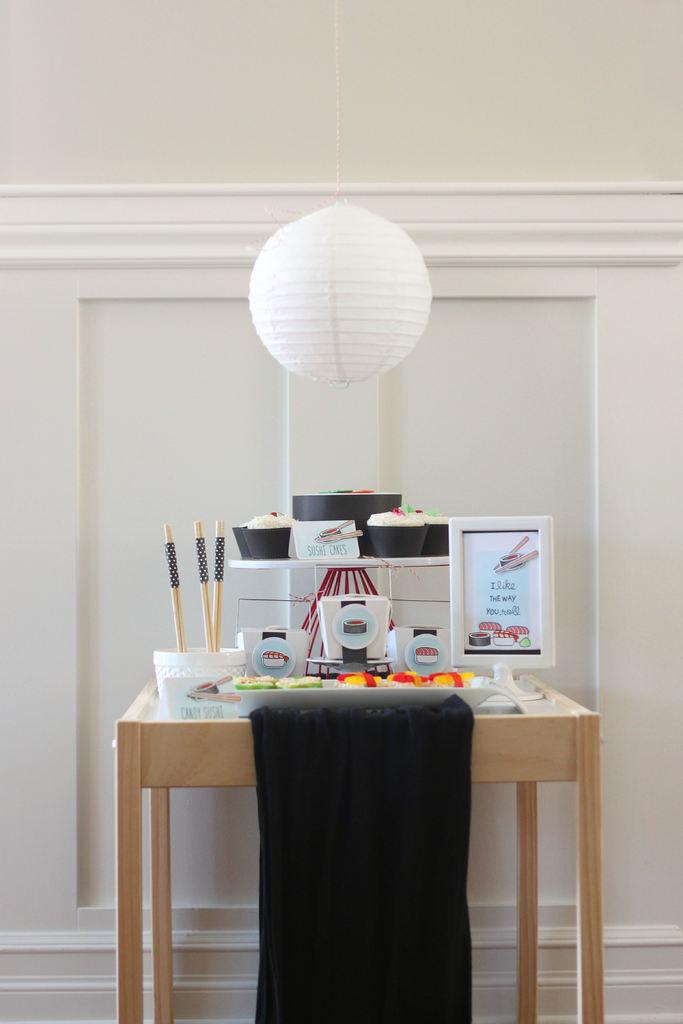<image>
Describe the image concisely. a sign that says The Way on it 